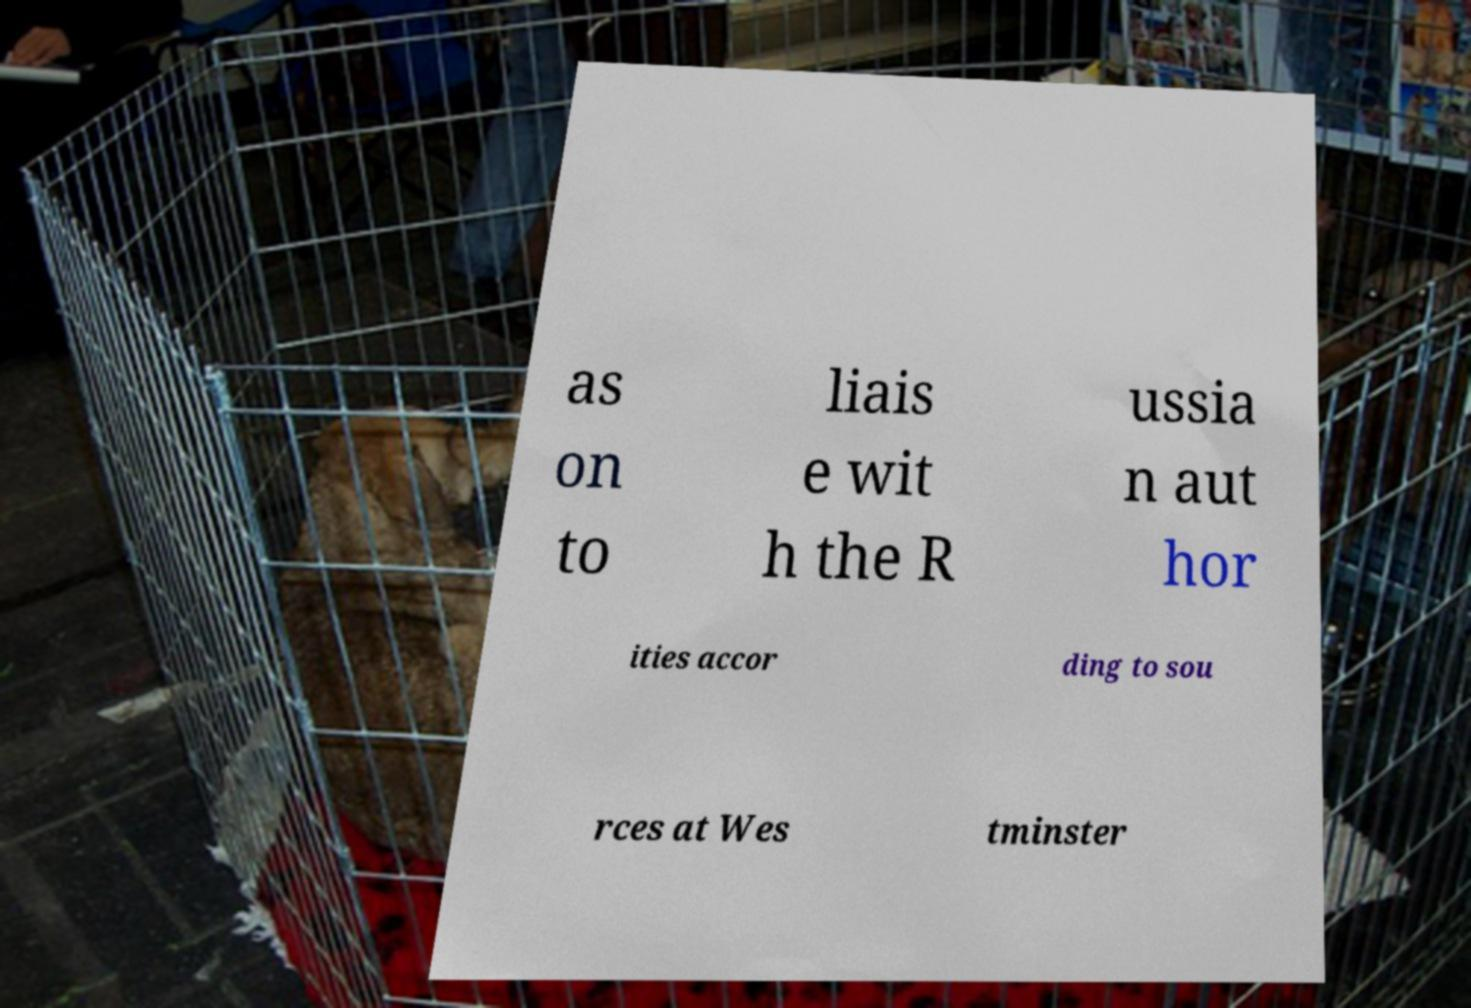Could you assist in decoding the text presented in this image and type it out clearly? as on to liais e wit h the R ussia n aut hor ities accor ding to sou rces at Wes tminster 